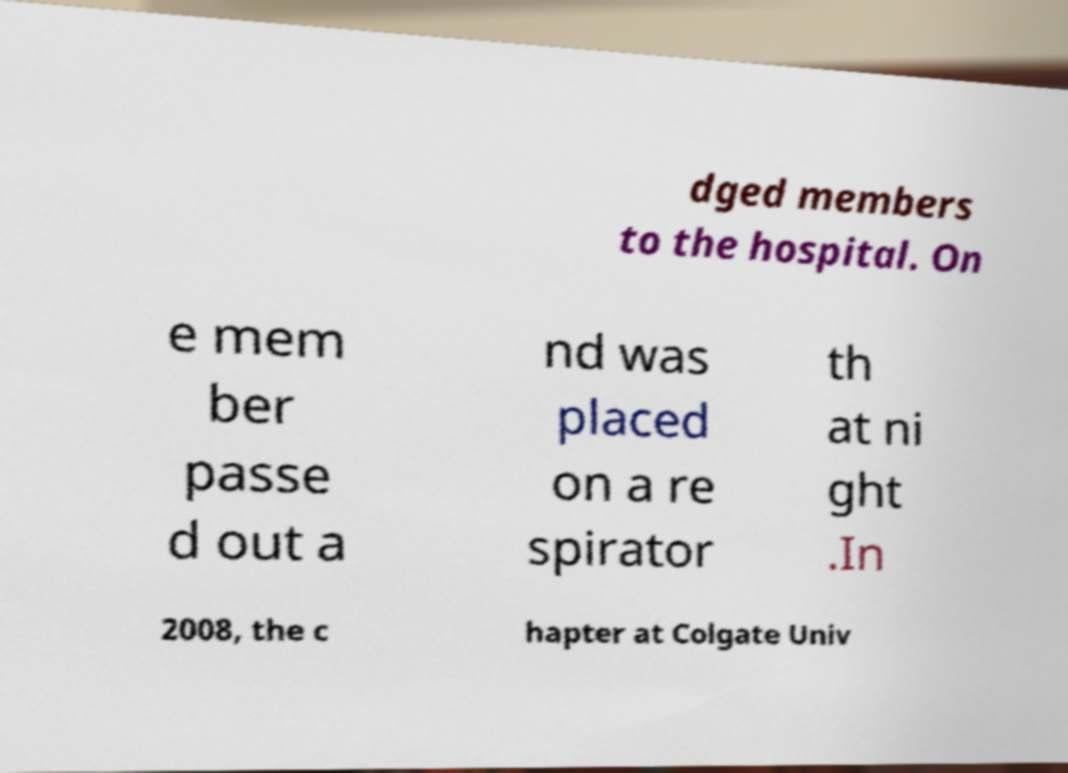Can you accurately transcribe the text from the provided image for me? dged members to the hospital. On e mem ber passe d out a nd was placed on a re spirator th at ni ght .In 2008, the c hapter at Colgate Univ 